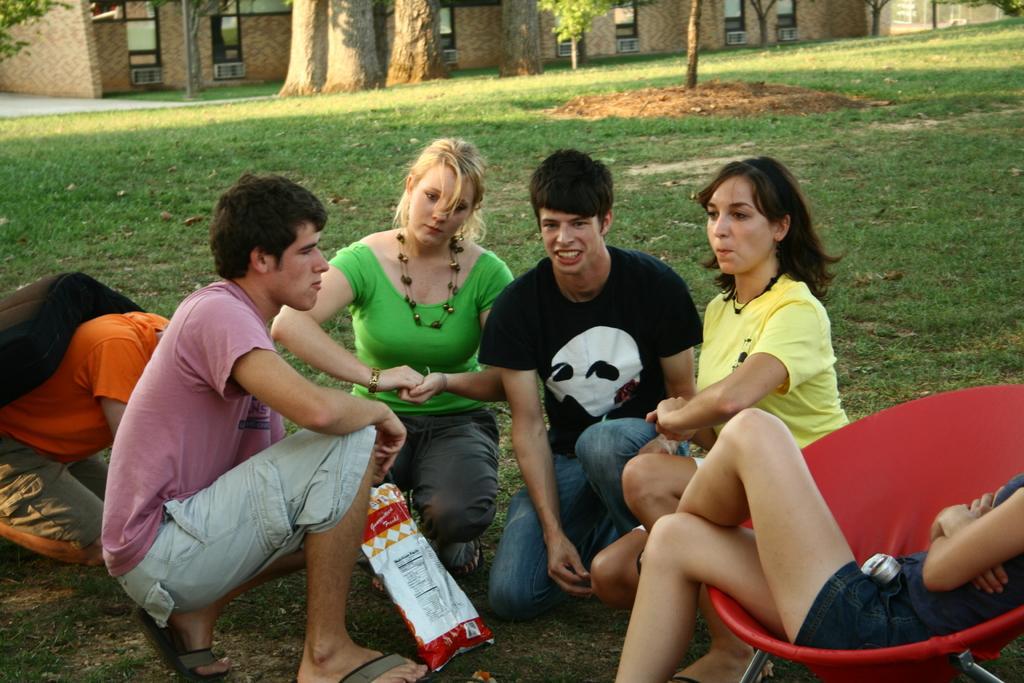Can you describe this image briefly? In the picture i can see that people are sitting in the garden and in the background i can see plants,trees,grass,sand. 